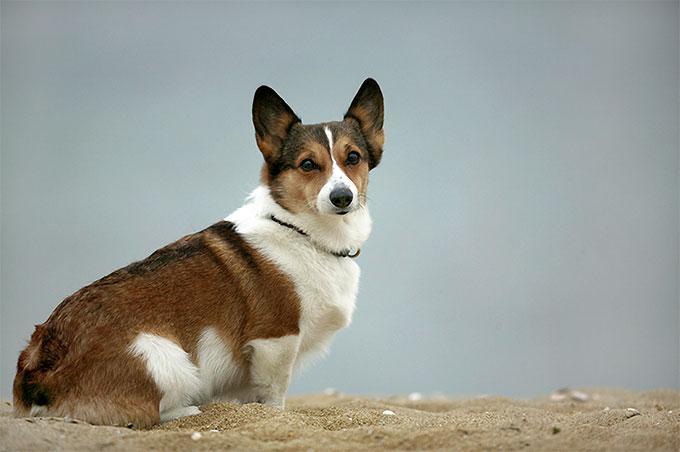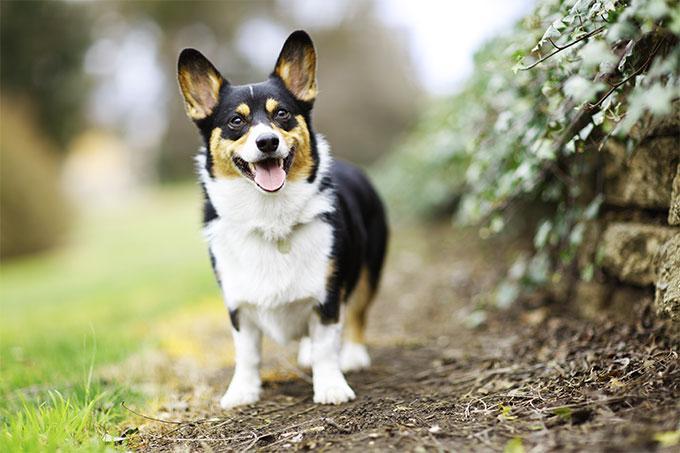The first image is the image on the left, the second image is the image on the right. For the images displayed, is the sentence "One of the images contains a dog that is sitting." factually correct? Answer yes or no. Yes. 